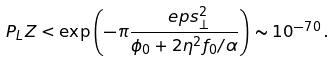<formula> <loc_0><loc_0><loc_500><loc_500>P _ { L } Z < \exp \left ( - \pi \frac { \ e p s _ { \bot } ^ { 2 } } { \phi _ { 0 } + 2 \eta ^ { 2 } f _ { 0 } / \alpha } \right ) \sim 1 0 ^ { - 7 0 } \, .</formula> 